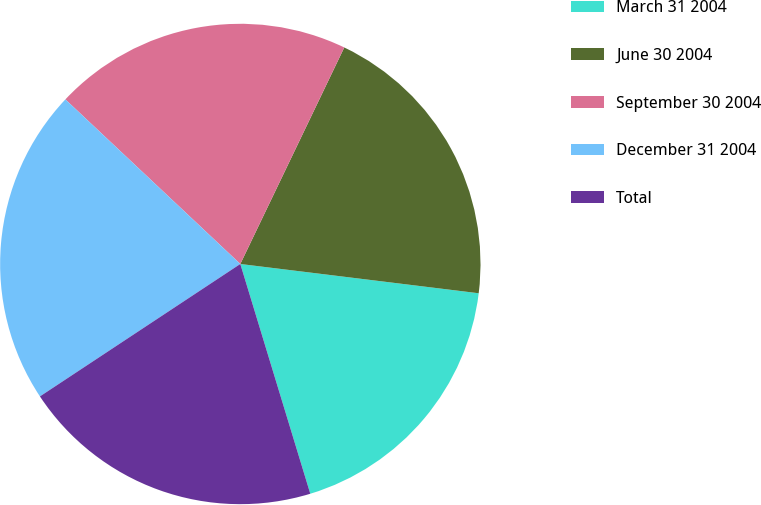Convert chart. <chart><loc_0><loc_0><loc_500><loc_500><pie_chart><fcel>March 31 2004<fcel>June 30 2004<fcel>September 30 2004<fcel>December 31 2004<fcel>Total<nl><fcel>18.35%<fcel>19.82%<fcel>20.11%<fcel>21.31%<fcel>20.41%<nl></chart> 